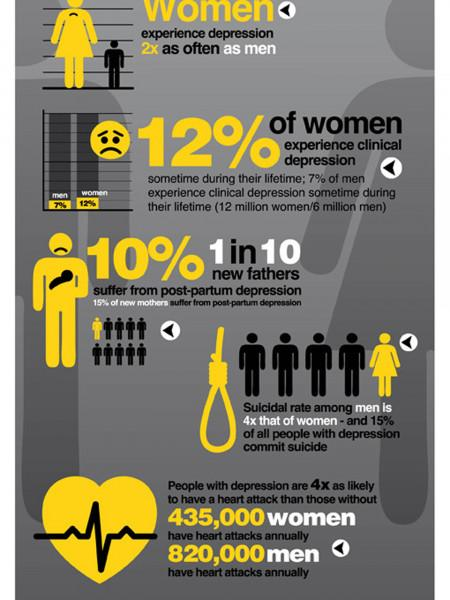Specify some key components in this picture. According to the given information, it can be inferred that out of every five people, one to four women tend to have a suicidal tendency, while the remaining person does not have any such tendency. 